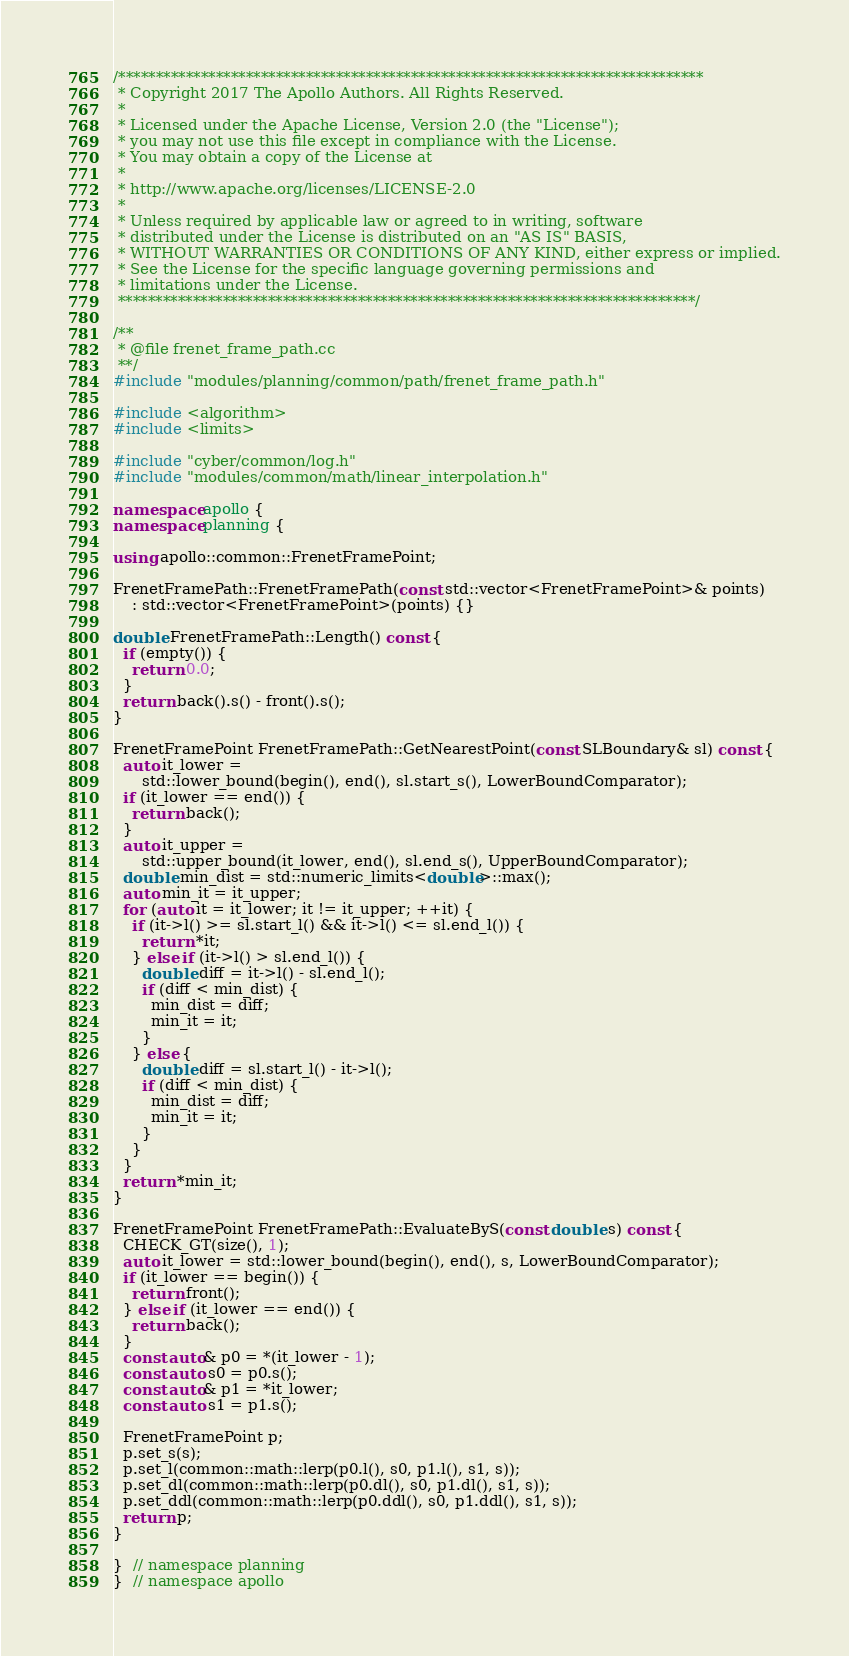Convert code to text. <code><loc_0><loc_0><loc_500><loc_500><_C++_>/******************************************************************************
 * Copyright 2017 The Apollo Authors. All Rights Reserved.
 *
 * Licensed under the Apache License, Version 2.0 (the "License");
 * you may not use this file except in compliance with the License.
 * You may obtain a copy of the License at
 *
 * http://www.apache.org/licenses/LICENSE-2.0
 *
 * Unless required by applicable law or agreed to in writing, software
 * distributed under the License is distributed on an "AS IS" BASIS,
 * WITHOUT WARRANTIES OR CONDITIONS OF ANY KIND, either express or implied.
 * See the License for the specific language governing permissions and
 * limitations under the License.
 *****************************************************************************/

/**
 * @file frenet_frame_path.cc
 **/
#include "modules/planning/common/path/frenet_frame_path.h"

#include <algorithm>
#include <limits>

#include "cyber/common/log.h"
#include "modules/common/math/linear_interpolation.h"

namespace apollo {
namespace planning {

using apollo::common::FrenetFramePoint;

FrenetFramePath::FrenetFramePath(const std::vector<FrenetFramePoint>& points)
    : std::vector<FrenetFramePoint>(points) {}

double FrenetFramePath::Length() const {
  if (empty()) {
    return 0.0;
  }
  return back().s() - front().s();
}

FrenetFramePoint FrenetFramePath::GetNearestPoint(const SLBoundary& sl) const {
  auto it_lower =
      std::lower_bound(begin(), end(), sl.start_s(), LowerBoundComparator);
  if (it_lower == end()) {
    return back();
  }
  auto it_upper =
      std::upper_bound(it_lower, end(), sl.end_s(), UpperBoundComparator);
  double min_dist = std::numeric_limits<double>::max();
  auto min_it = it_upper;
  for (auto it = it_lower; it != it_upper; ++it) {
    if (it->l() >= sl.start_l() && it->l() <= sl.end_l()) {
      return *it;
    } else if (it->l() > sl.end_l()) {
      double diff = it->l() - sl.end_l();
      if (diff < min_dist) {
        min_dist = diff;
        min_it = it;
      }
    } else {
      double diff = sl.start_l() - it->l();
      if (diff < min_dist) {
        min_dist = diff;
        min_it = it;
      }
    }
  }
  return *min_it;
}

FrenetFramePoint FrenetFramePath::EvaluateByS(const double s) const {
  CHECK_GT(size(), 1);
  auto it_lower = std::lower_bound(begin(), end(), s, LowerBoundComparator);
  if (it_lower == begin()) {
    return front();
  } else if (it_lower == end()) {
    return back();
  }
  const auto& p0 = *(it_lower - 1);
  const auto s0 = p0.s();
  const auto& p1 = *it_lower;
  const auto s1 = p1.s();

  FrenetFramePoint p;
  p.set_s(s);
  p.set_l(common::math::lerp(p0.l(), s0, p1.l(), s1, s));
  p.set_dl(common::math::lerp(p0.dl(), s0, p1.dl(), s1, s));
  p.set_ddl(common::math::lerp(p0.ddl(), s0, p1.ddl(), s1, s));
  return p;
}

}  // namespace planning
}  // namespace apollo
</code> 